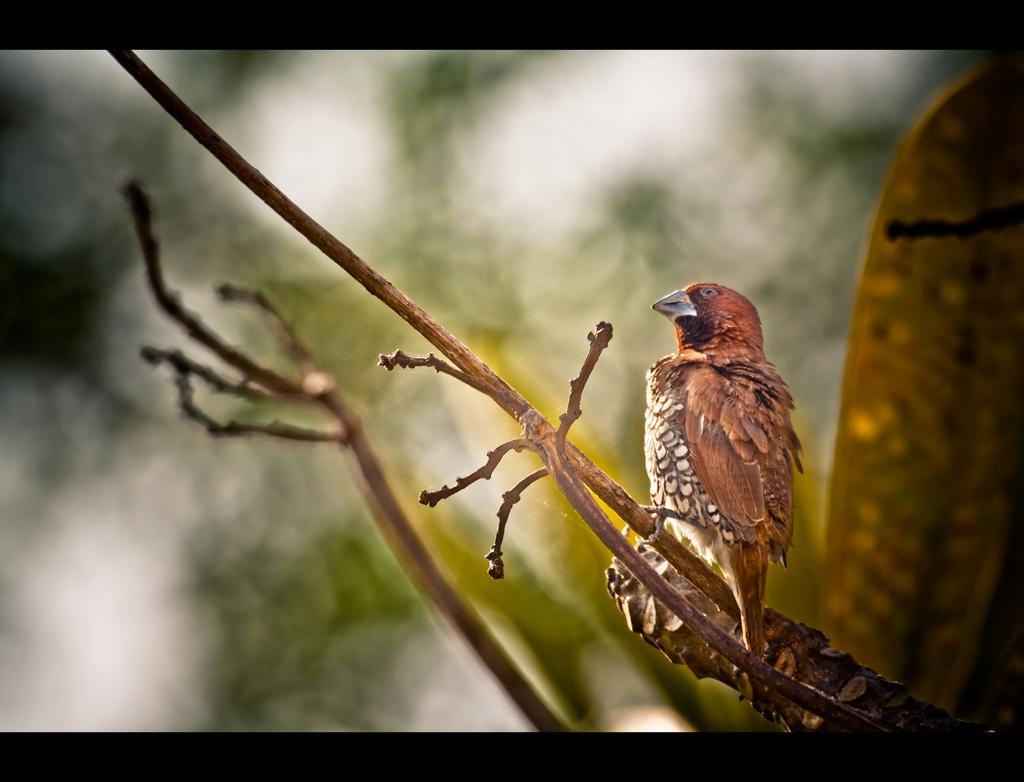Could you give a brief overview of what you see in this image? On the right side, there is a bird standing on a branch of a tree. And the background is blurred. 